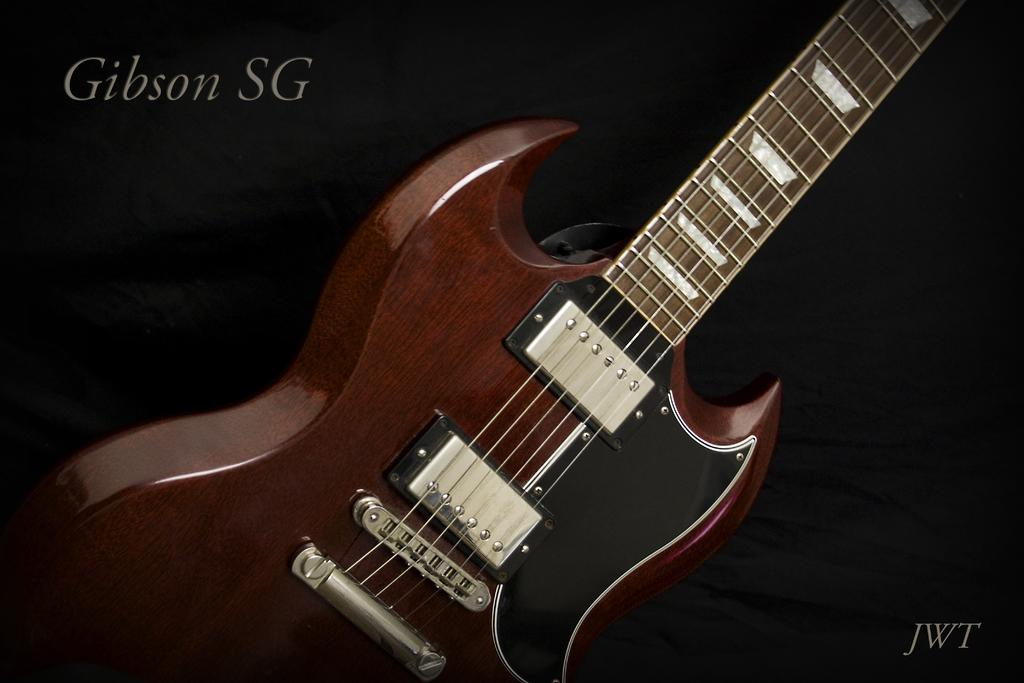What musical instrument is present in the image? There is a guitar in the image. What type of scale can be seen on the guitar in the image? There is no scale visible on the guitar in the image. Is there any soda present in the image? There is no soda present in the image. 